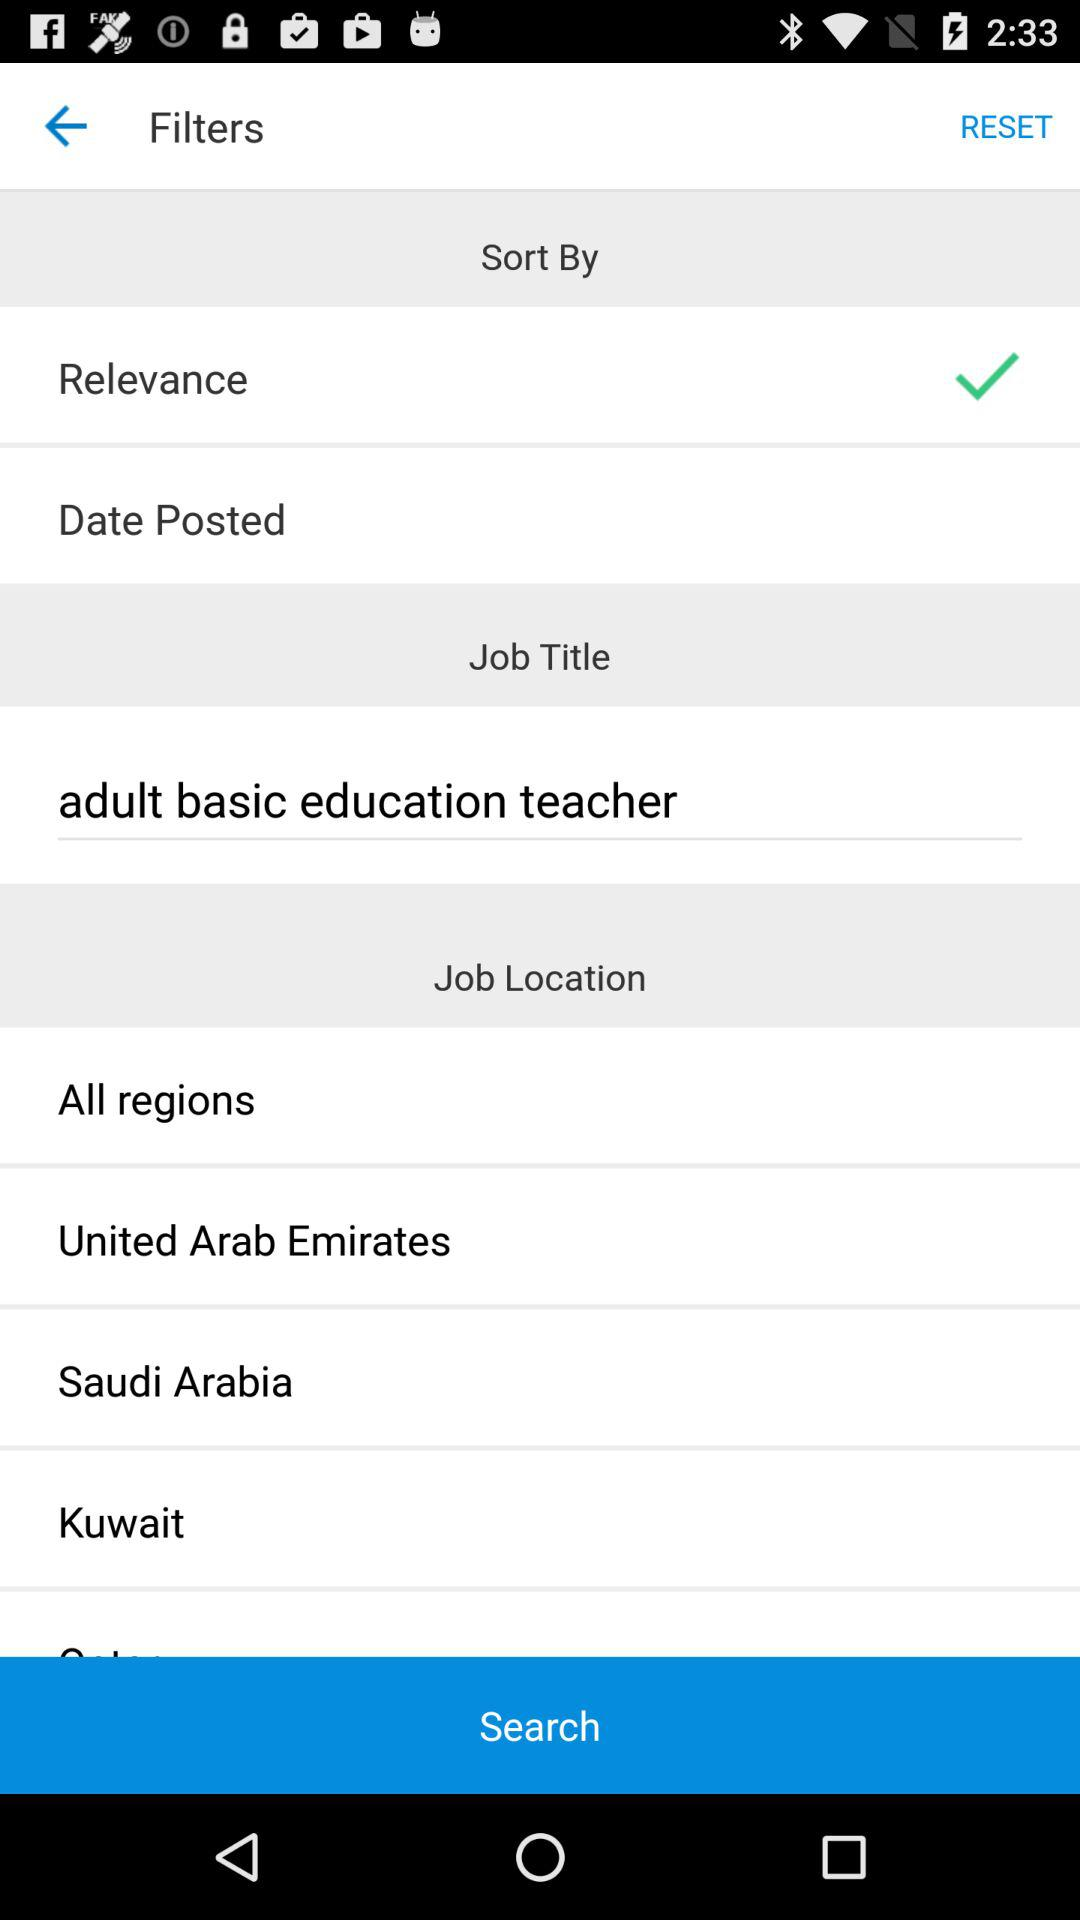What is the location of the job?
When the provided information is insufficient, respond with <no answer>. <no answer> 